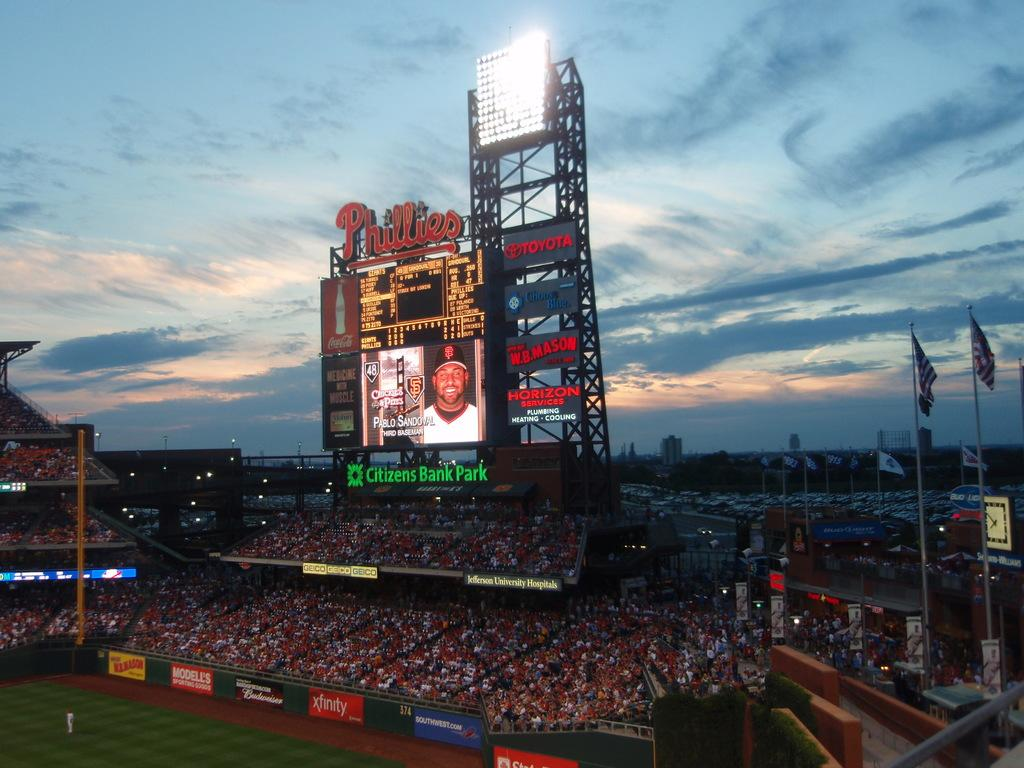<image>
Share a concise interpretation of the image provided. A large, outdoor sports arena called the Citizens Bank Park. 